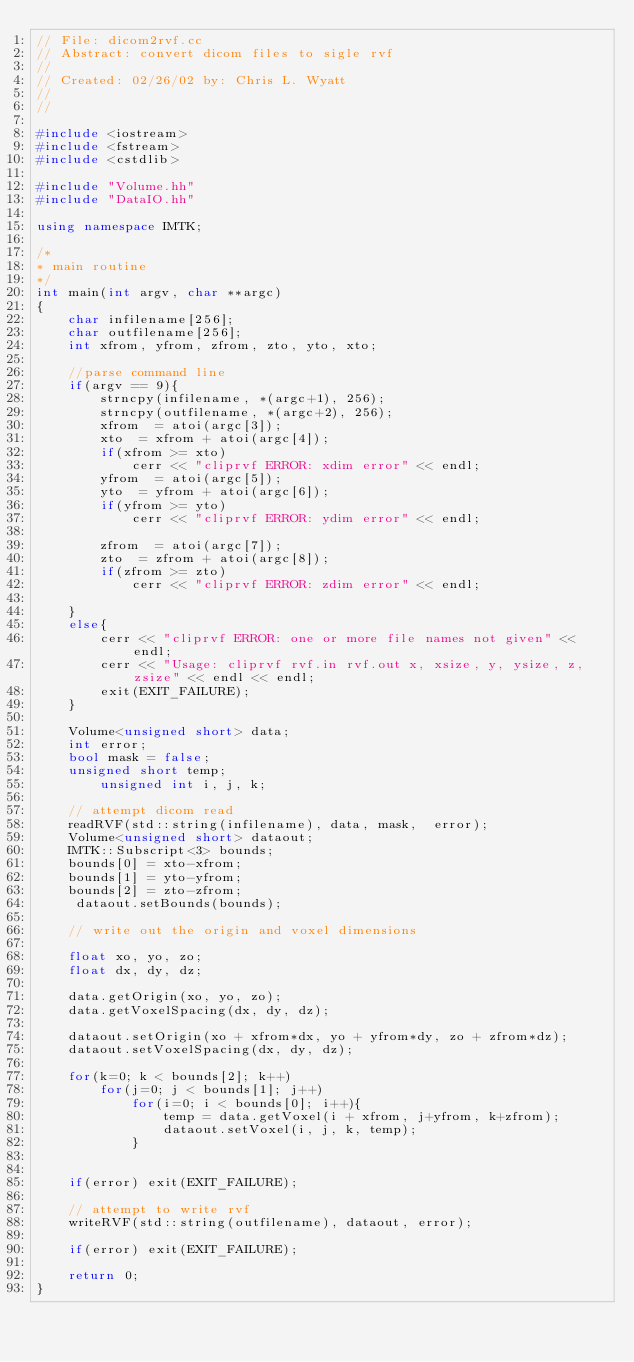<code> <loc_0><loc_0><loc_500><loc_500><_C++_>// File: dicom2rvf.cc
// Abstract: convert dicom files to sigle rvf
//
// Created: 02/26/02 by: Chris L. Wyatt
//
//                

#include <iostream>
#include <fstream>
#include <cstdlib>

#include "Volume.hh"
#include "DataIO.hh"

using namespace IMTK;

/*
* main routine
*/
int main(int argv, char **argc)
{
	char infilename[256];
	char outfilename[256];
	int xfrom, yfrom, zfrom, zto, yto, xto;

	//parse command line
	if(argv == 9){
		strncpy(infilename, *(argc+1), 256);
		strncpy(outfilename, *(argc+2), 256);
		xfrom  = atoi(argc[3]);
		xto  = xfrom + atoi(argc[4]);
		if(xfrom >= xto) 
			cerr << "cliprvf ERROR: xdim error" << endl;
		yfrom  = atoi(argc[5]);
		yto  = yfrom + atoi(argc[6]);
		if(yfrom >= yto) 
			cerr << "cliprvf ERROR: ydim error" << endl;

		zfrom  = atoi(argc[7]);
		zto  = zfrom + atoi(argc[8]);
		if(zfrom >= zto) 
			cerr << "cliprvf ERROR: zdim error" << endl;
		 
	}
	else{
		cerr << "cliprvf ERROR: one or more file names not given" << endl;
		cerr << "Usage: cliprvf rvf.in rvf.out x, xsize, y, ysize, z, zsize" << endl << endl;
		exit(EXIT_FAILURE);
	}

	Volume<unsigned short> data;
	int error;
	bool mask = false;
	unsigned short temp;
        unsigned int i, j, k;

	// attempt dicom read
	readRVF(std::string(infilename), data, mask,  error);
	Volume<unsigned short> dataout;
	IMTK::Subscript<3> bounds;
	bounds[0] = xto-xfrom;
	bounds[1] = yto-yfrom;
	bounds[2] = zto-zfrom;
	 dataout.setBounds(bounds);

	// write out the origin and voxel dimensions	

	float xo, yo, zo;
	float dx, dy, dz;

	data.getOrigin(xo, yo, zo);
	data.getVoxelSpacing(dx, dy, dz);

	dataout.setOrigin(xo + xfrom*dx, yo + yfrom*dy, zo + zfrom*dz);
	dataout.setVoxelSpacing(dx, dy, dz);
	
	for(k=0; k < bounds[2]; k++)
		for(j=0; j < bounds[1]; j++)
			for(i=0; i < bounds[0]; i++){
				temp = data.getVoxel(i + xfrom, j+yfrom, k+zfrom);
				dataout.setVoxel(i, j, k, temp);
			}
	

	if(error) exit(EXIT_FAILURE);

	// attempt to write rvf
	writeRVF(std::string(outfilename), dataout, error);

	if(error) exit(EXIT_FAILURE);

	return 0;
}


</code> 